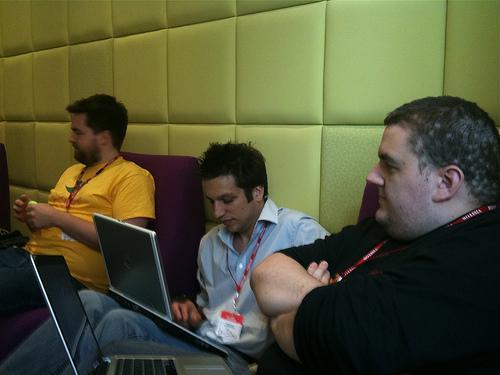How many people are shown?
Give a very brief answer. 3. How many computers are shown?
Give a very brief answer. 2. How many name badges can be seen?
Give a very brief answer. 3. How many people are reading book?
Give a very brief answer. 0. 